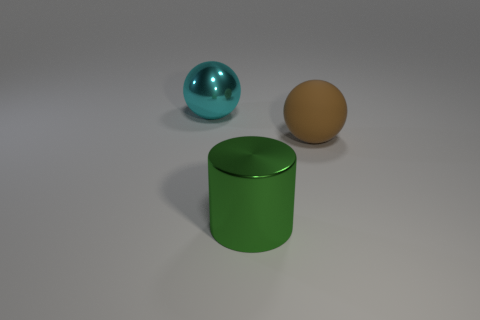What number of other objects are there of the same size as the cyan metallic ball?
Your response must be concise. 2. There is a brown matte sphere; is it the same size as the sphere left of the big brown object?
Your response must be concise. Yes. What is the color of the cylinder that is the same size as the cyan metal sphere?
Give a very brief answer. Green. The green metallic cylinder has what size?
Provide a succinct answer. Large. Is the sphere that is right of the metallic sphere made of the same material as the big cyan sphere?
Your response must be concise. No. Is the shape of the cyan shiny thing the same as the green thing?
Provide a succinct answer. No. There is a big metal thing that is to the right of the object on the left side of the metallic thing in front of the big brown matte object; what is its shape?
Provide a succinct answer. Cylinder. Is the shape of the big object that is left of the green thing the same as the big thing on the right side of the cylinder?
Give a very brief answer. Yes. Is there a tiny gray cube that has the same material as the green thing?
Provide a succinct answer. No. There is a thing behind the big ball right of the object that is behind the rubber ball; what color is it?
Provide a short and direct response. Cyan. 